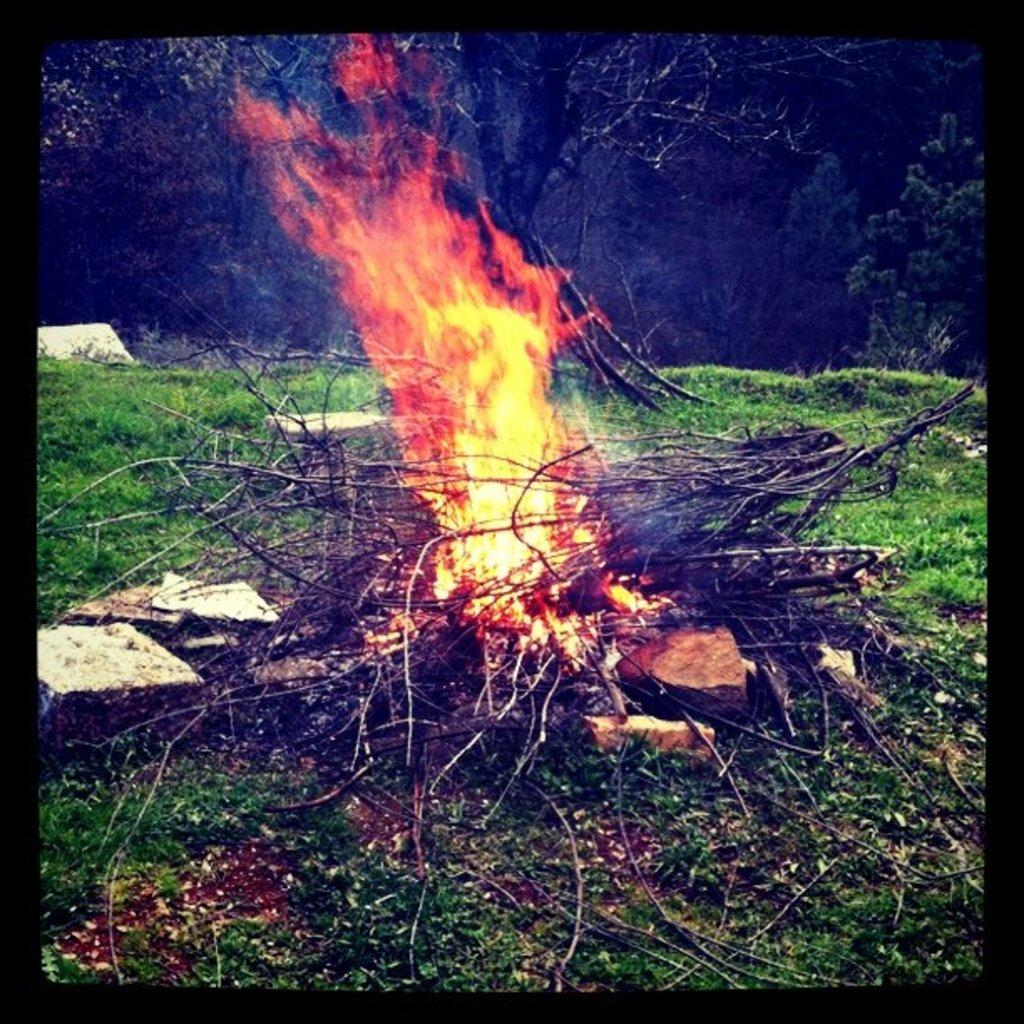What type of vegetation is present in the image? There is grass in the image. What other objects can be seen in the image? There are stones and sticks visible in the image. What is happening in the image? There is a fire in the image. What can be seen in the background of the image? There are trees visible in the background of the image. What type of wrist accessory can be seen in the image? There is no wrist accessory present in the image. 